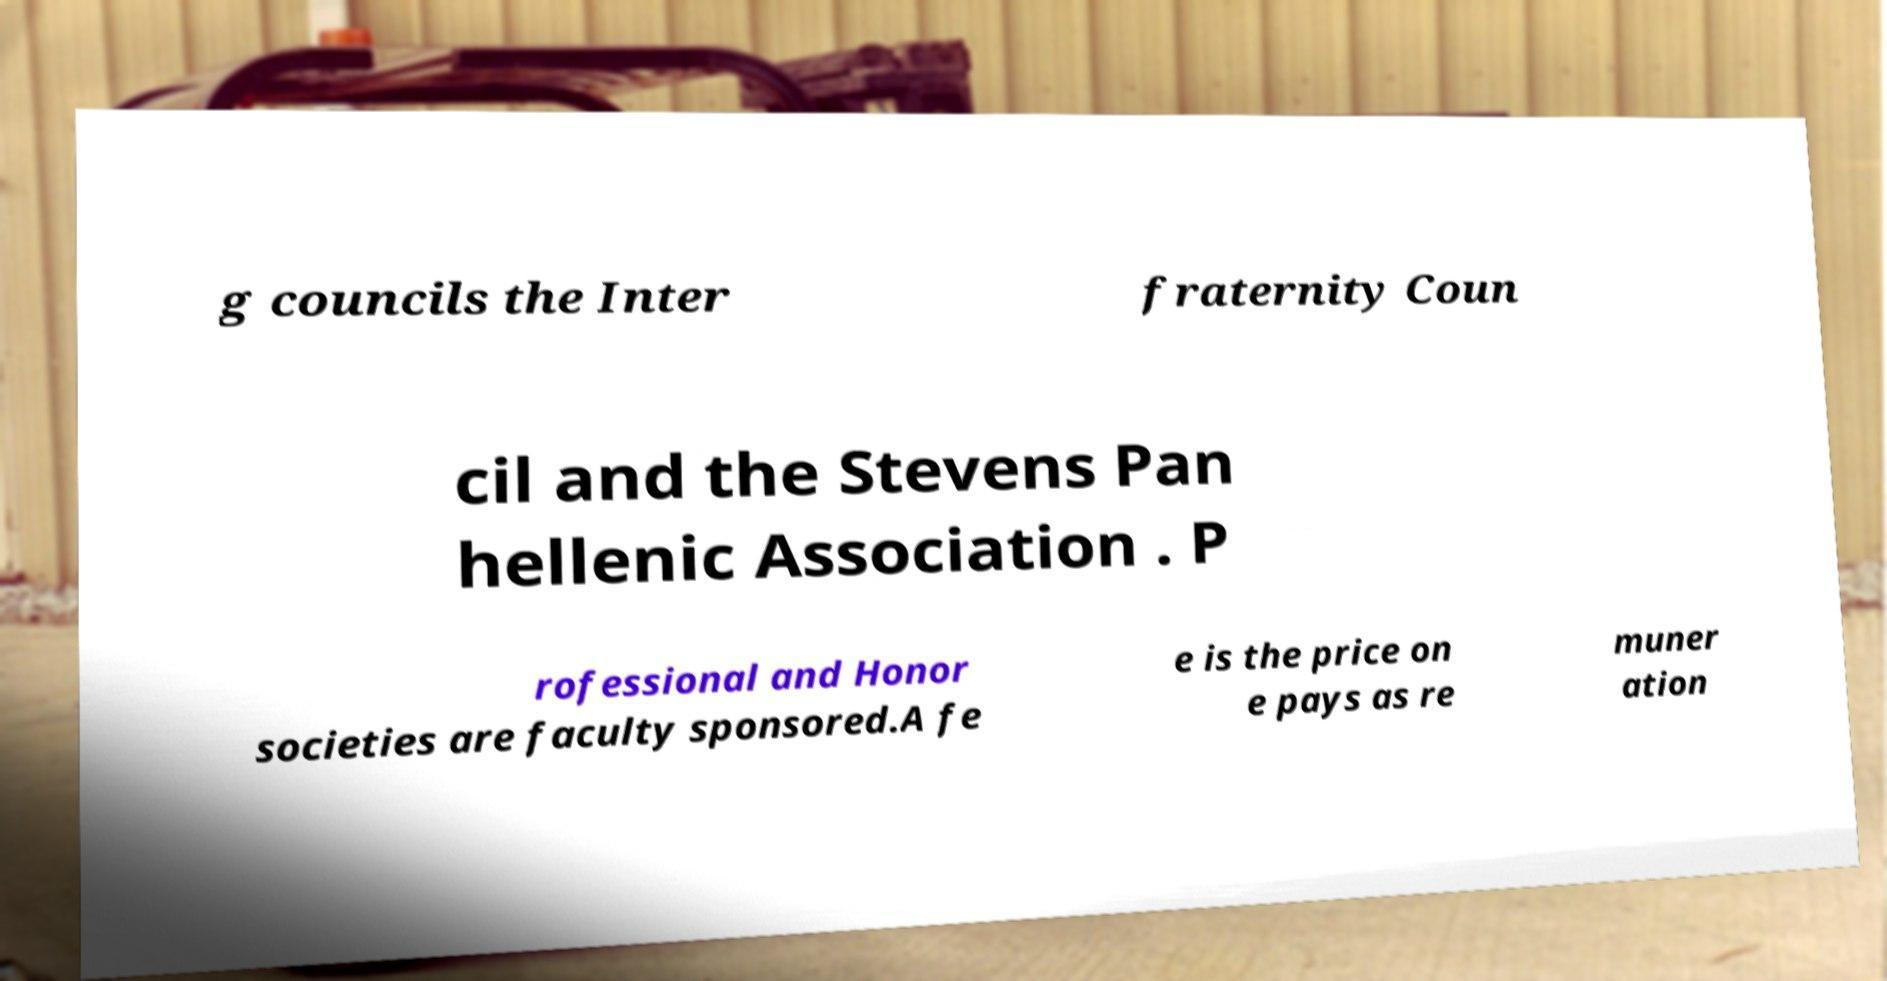For documentation purposes, I need the text within this image transcribed. Could you provide that? g councils the Inter fraternity Coun cil and the Stevens Pan hellenic Association . P rofessional and Honor societies are faculty sponsored.A fe e is the price on e pays as re muner ation 